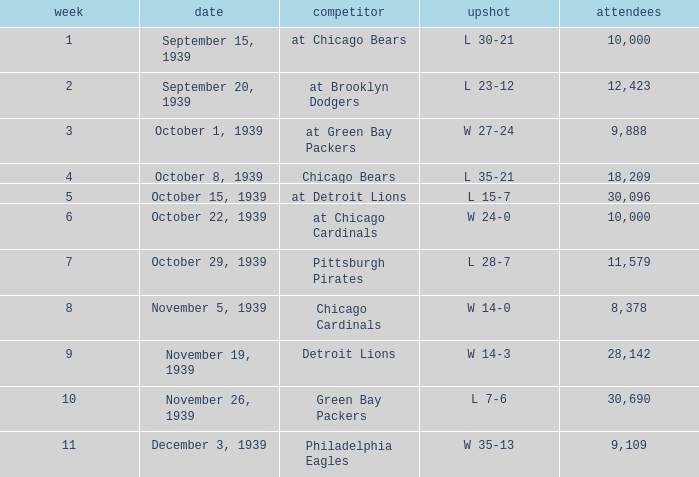What sum of Attendance has a Week smaller than 10, and a Result of l 30-21? 10000.0. 